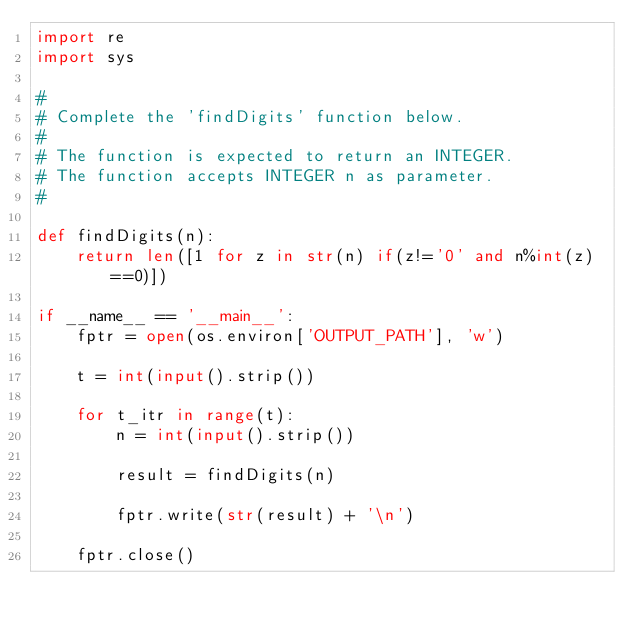<code> <loc_0><loc_0><loc_500><loc_500><_Python_>import re
import sys

#
# Complete the 'findDigits' function below.
#
# The function is expected to return an INTEGER.
# The function accepts INTEGER n as parameter.
#

def findDigits(n):
    return len([1 for z in str(n) if(z!='0' and n%int(z)==0)])

if __name__ == '__main__':
    fptr = open(os.environ['OUTPUT_PATH'], 'w')

    t = int(input().strip())

    for t_itr in range(t):
        n = int(input().strip())

        result = findDigits(n)

        fptr.write(str(result) + '\n')

    fptr.close()</code> 